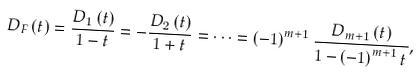Convert formula to latex. <formula><loc_0><loc_0><loc_500><loc_500>D _ { F } \left ( t \right ) = \frac { D _ { 1 } \left ( t \right ) } { 1 - t } = - \frac { D _ { 2 } \left ( t \right ) } { 1 + t } = \dots = \left ( - 1 \right ) ^ { m + 1 } \frac { D _ { m + 1 } \left ( t \right ) } { 1 - \left ( - 1 \right ) ^ { m + 1 } t } ,</formula> 